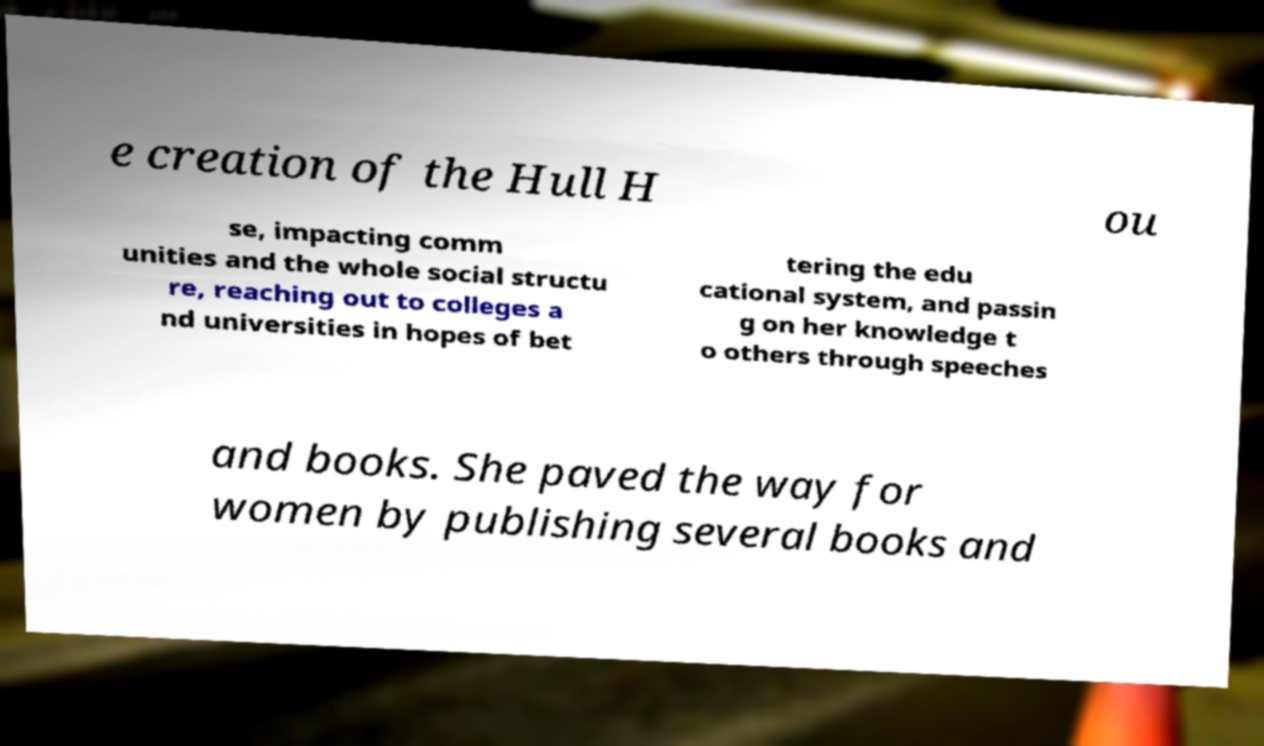Could you extract and type out the text from this image? e creation of the Hull H ou se, impacting comm unities and the whole social structu re, reaching out to colleges a nd universities in hopes of bet tering the edu cational system, and passin g on her knowledge t o others through speeches and books. She paved the way for women by publishing several books and 